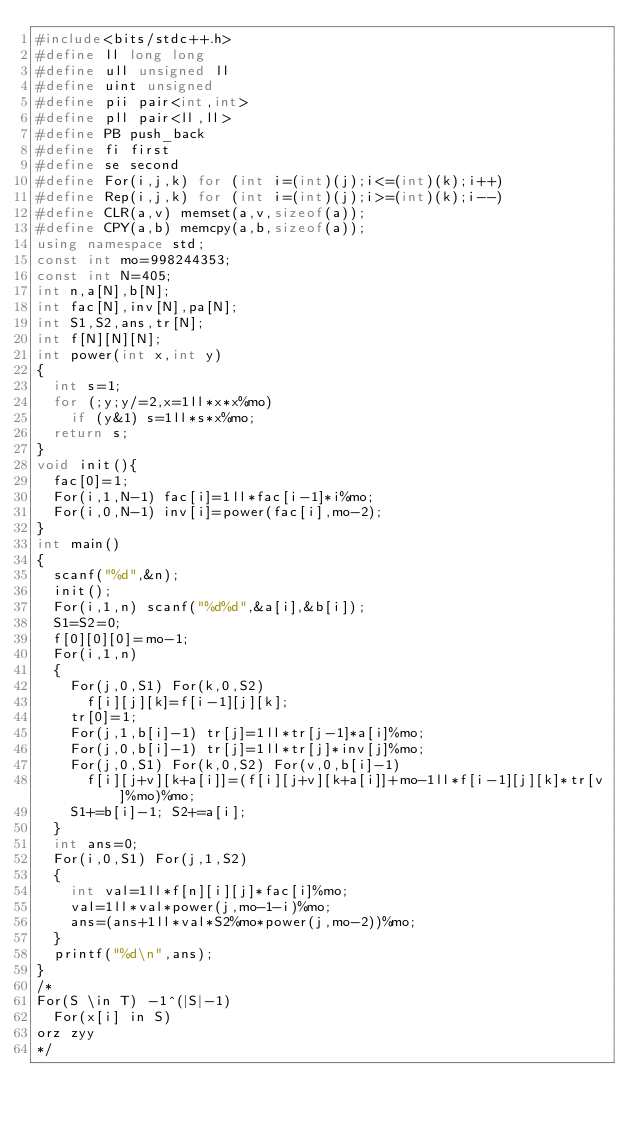<code> <loc_0><loc_0><loc_500><loc_500><_C++_>#include<bits/stdc++.h>
#define ll long long
#define ull unsigned ll
#define uint unsigned
#define pii pair<int,int>
#define pll pair<ll,ll>
#define PB push_back
#define fi first
#define se second
#define For(i,j,k) for (int i=(int)(j);i<=(int)(k);i++)
#define Rep(i,j,k) for (int i=(int)(j);i>=(int)(k);i--)
#define CLR(a,v) memset(a,v,sizeof(a));
#define CPY(a,b) memcpy(a,b,sizeof(a));
using namespace std;
const int mo=998244353;
const int N=405;
int n,a[N],b[N];
int fac[N],inv[N],pa[N];
int S1,S2,ans,tr[N];
int f[N][N][N];
int power(int x,int y)
{
	int s=1;
	for (;y;y/=2,x=1ll*x*x%mo)
		if (y&1) s=1ll*s*x%mo;
	return s;
}
void init(){
	fac[0]=1;
	For(i,1,N-1) fac[i]=1ll*fac[i-1]*i%mo;
	For(i,0,N-1) inv[i]=power(fac[i],mo-2);
}
int main()
{
	scanf("%d",&n);
	init();
	For(i,1,n) scanf("%d%d",&a[i],&b[i]);
	S1=S2=0;
	f[0][0][0]=mo-1;
	For(i,1,n)
	{
		For(j,0,S1) For(k,0,S2)
			f[i][j][k]=f[i-1][j][k];
		tr[0]=1;
		For(j,1,b[i]-1) tr[j]=1ll*tr[j-1]*a[i]%mo;
		For(j,0,b[i]-1) tr[j]=1ll*tr[j]*inv[j]%mo;
		For(j,0,S1) For(k,0,S2) For(v,0,b[i]-1)
			f[i][j+v][k+a[i]]=(f[i][j+v][k+a[i]]+mo-1ll*f[i-1][j][k]*tr[v]%mo)%mo;		
		S1+=b[i]-1; S2+=a[i];
	}
	int ans=0;
	For(i,0,S1) For(j,1,S2)
	{
		int val=1ll*f[n][i][j]*fac[i]%mo;
		val=1ll*val*power(j,mo-1-i)%mo;
		ans=(ans+1ll*val*S2%mo*power(j,mo-2))%mo;
	}
	printf("%d\n",ans);
}
/*
For(S \in T) -1^(|S|-1)
	For(x[i] in S)
orz zyy	
*/
</code> 